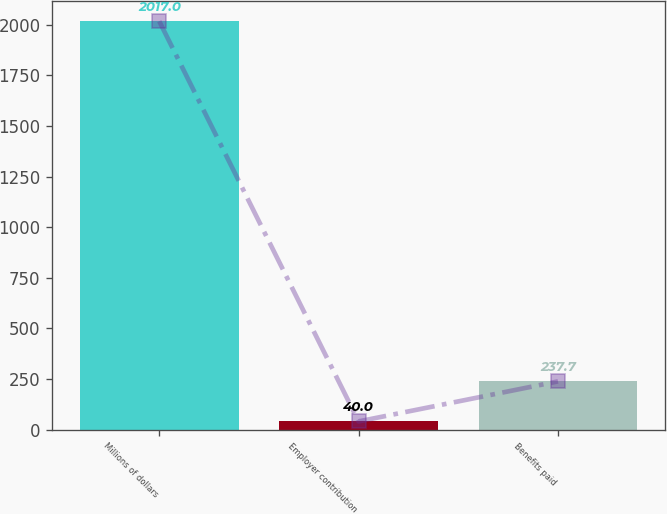Convert chart. <chart><loc_0><loc_0><loc_500><loc_500><bar_chart><fcel>Millions of dollars<fcel>Employer contribution<fcel>Benefits paid<nl><fcel>2017<fcel>40<fcel>237.7<nl></chart> 